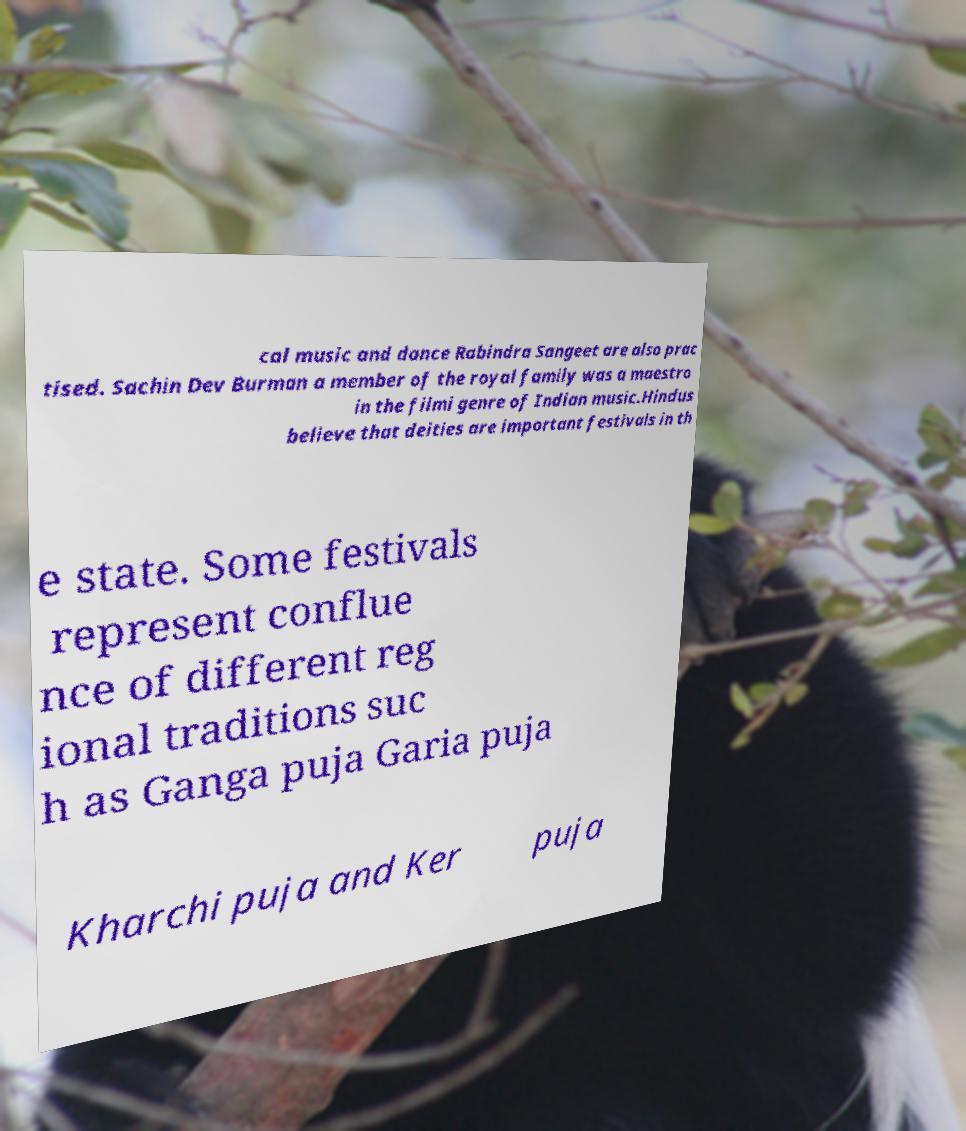Please identify and transcribe the text found in this image. cal music and dance Rabindra Sangeet are also prac tised. Sachin Dev Burman a member of the royal family was a maestro in the filmi genre of Indian music.Hindus believe that deities are important festivals in th e state. Some festivals represent conflue nce of different reg ional traditions suc h as Ganga puja Garia puja Kharchi puja and Ker puja 